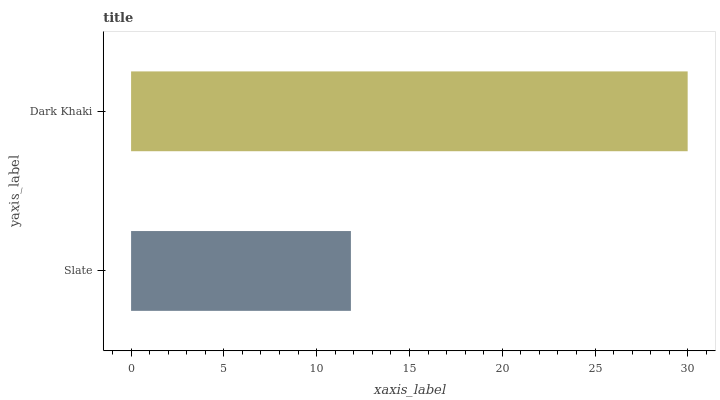Is Slate the minimum?
Answer yes or no. Yes. Is Dark Khaki the maximum?
Answer yes or no. Yes. Is Dark Khaki the minimum?
Answer yes or no. No. Is Dark Khaki greater than Slate?
Answer yes or no. Yes. Is Slate less than Dark Khaki?
Answer yes or no. Yes. Is Slate greater than Dark Khaki?
Answer yes or no. No. Is Dark Khaki less than Slate?
Answer yes or no. No. Is Dark Khaki the high median?
Answer yes or no. Yes. Is Slate the low median?
Answer yes or no. Yes. Is Slate the high median?
Answer yes or no. No. Is Dark Khaki the low median?
Answer yes or no. No. 